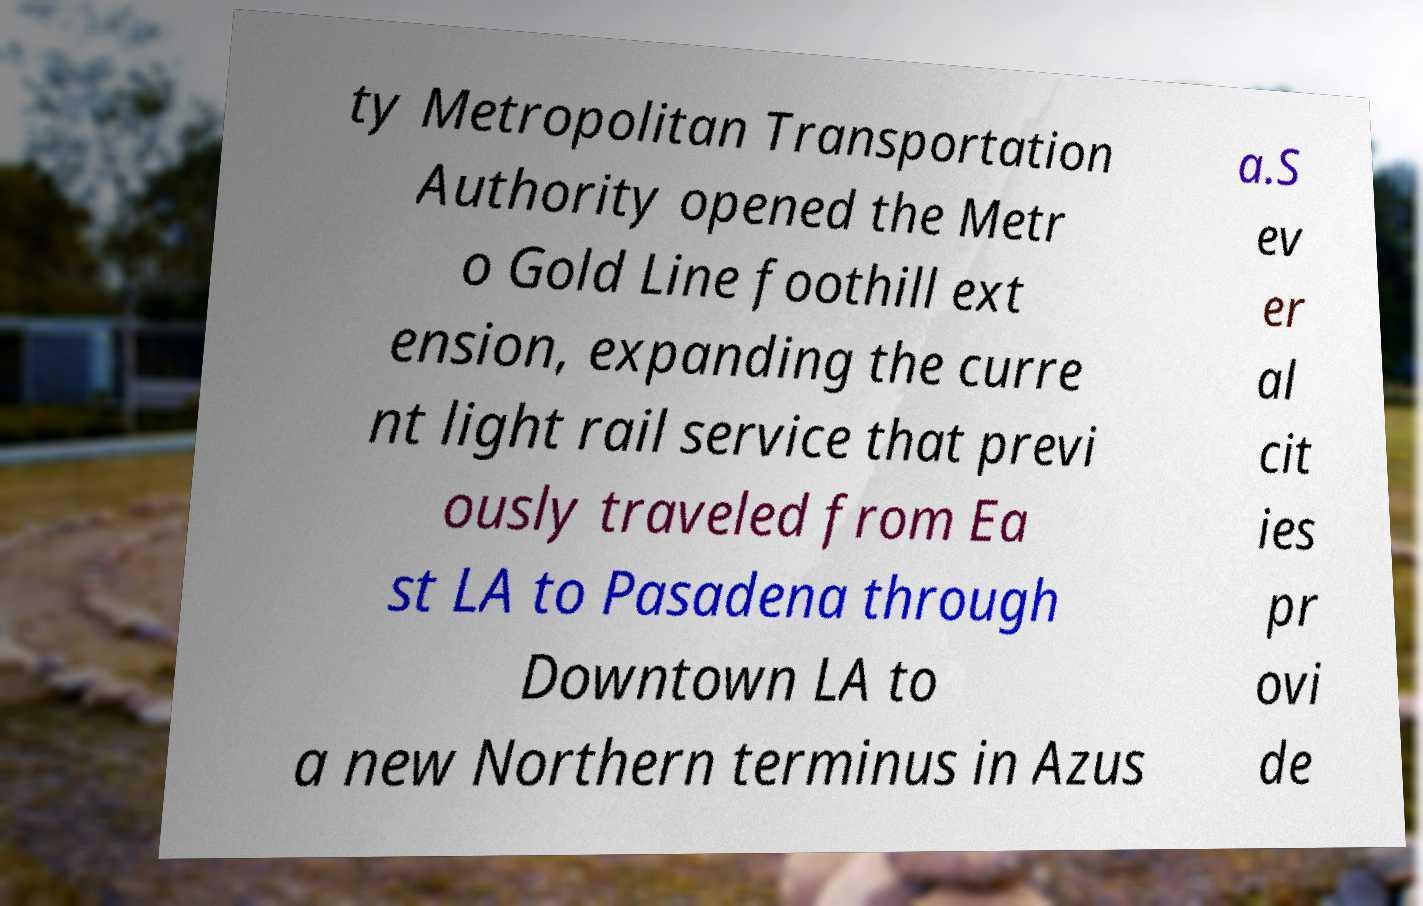For documentation purposes, I need the text within this image transcribed. Could you provide that? ty Metropolitan Transportation Authority opened the Metr o Gold Line foothill ext ension, expanding the curre nt light rail service that previ ously traveled from Ea st LA to Pasadena through Downtown LA to a new Northern terminus in Azus a.S ev er al cit ies pr ovi de 